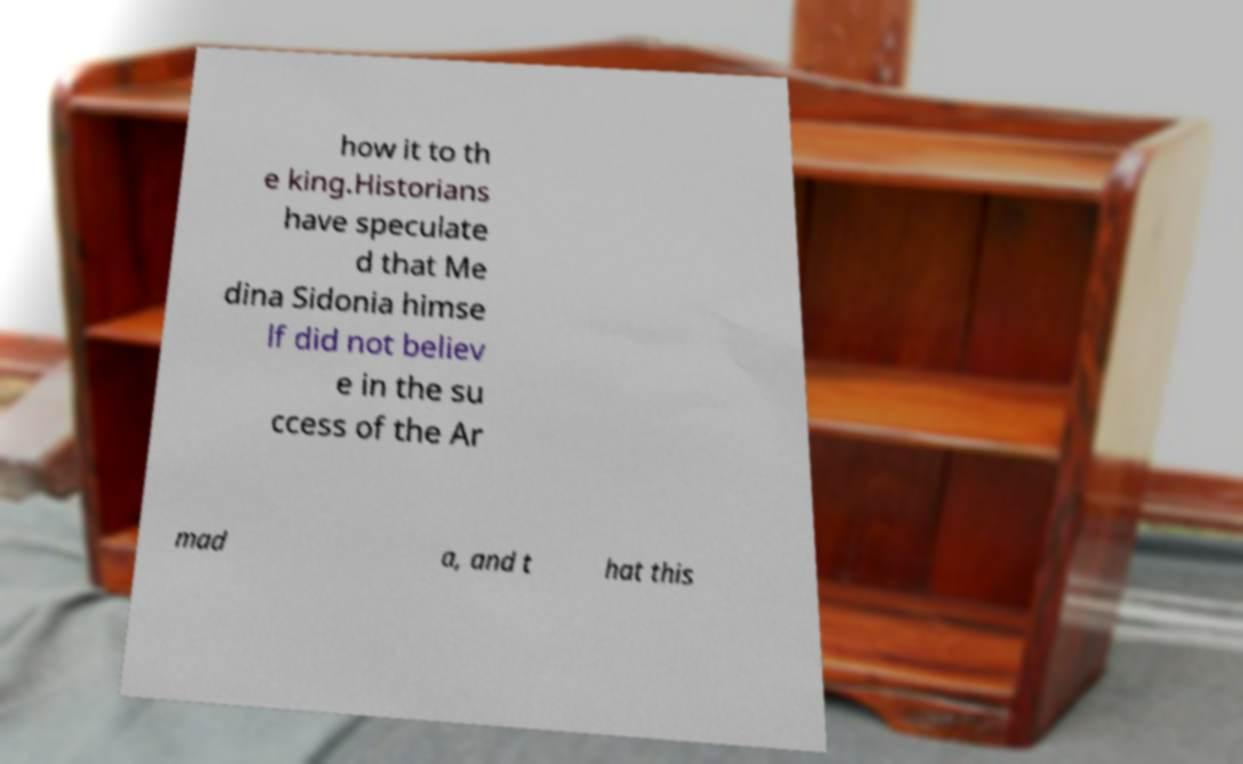For documentation purposes, I need the text within this image transcribed. Could you provide that? how it to th e king.Historians have speculate d that Me dina Sidonia himse lf did not believ e in the su ccess of the Ar mad a, and t hat this 